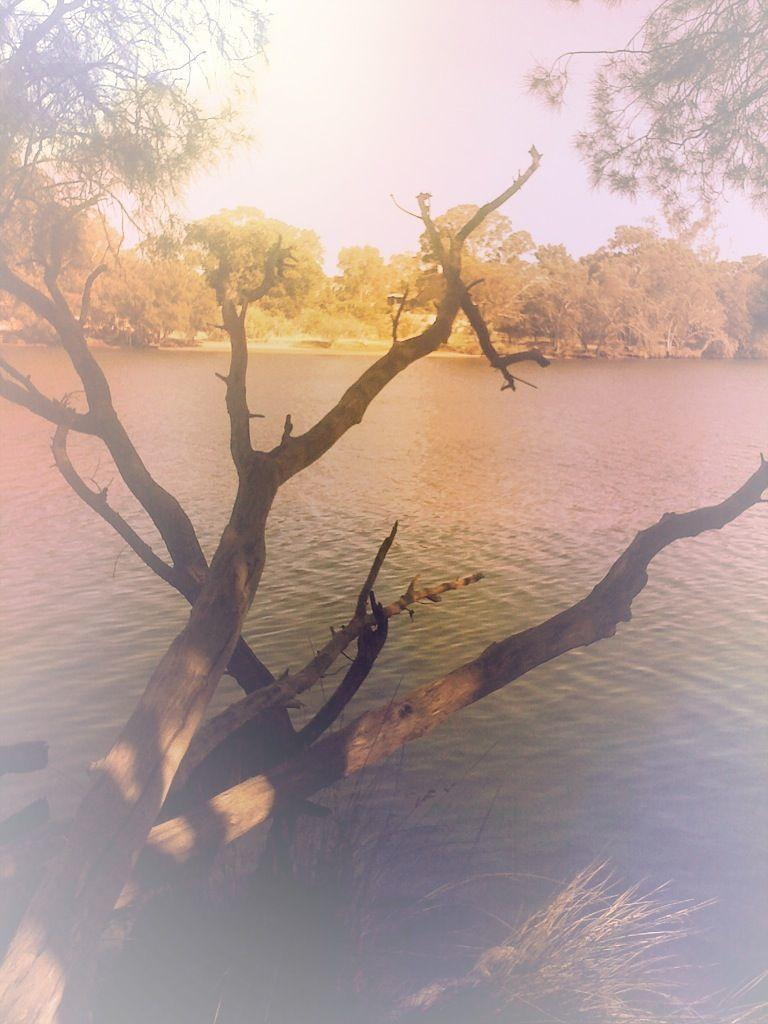What is the main object in the foreground of the image? There is a branch of a tree in the image. What can be seen in the image besides the tree branch? Water is visible in the image. What is visible in the background of the image? There are many trees and the sky in the background of the image. Can you see a cat playing with a wire in the image? There is no cat or wire present in the image. How many clovers are growing near the tree branch in the image? There is no mention of clovers in the image, so we cannot determine their presence or quantity. 